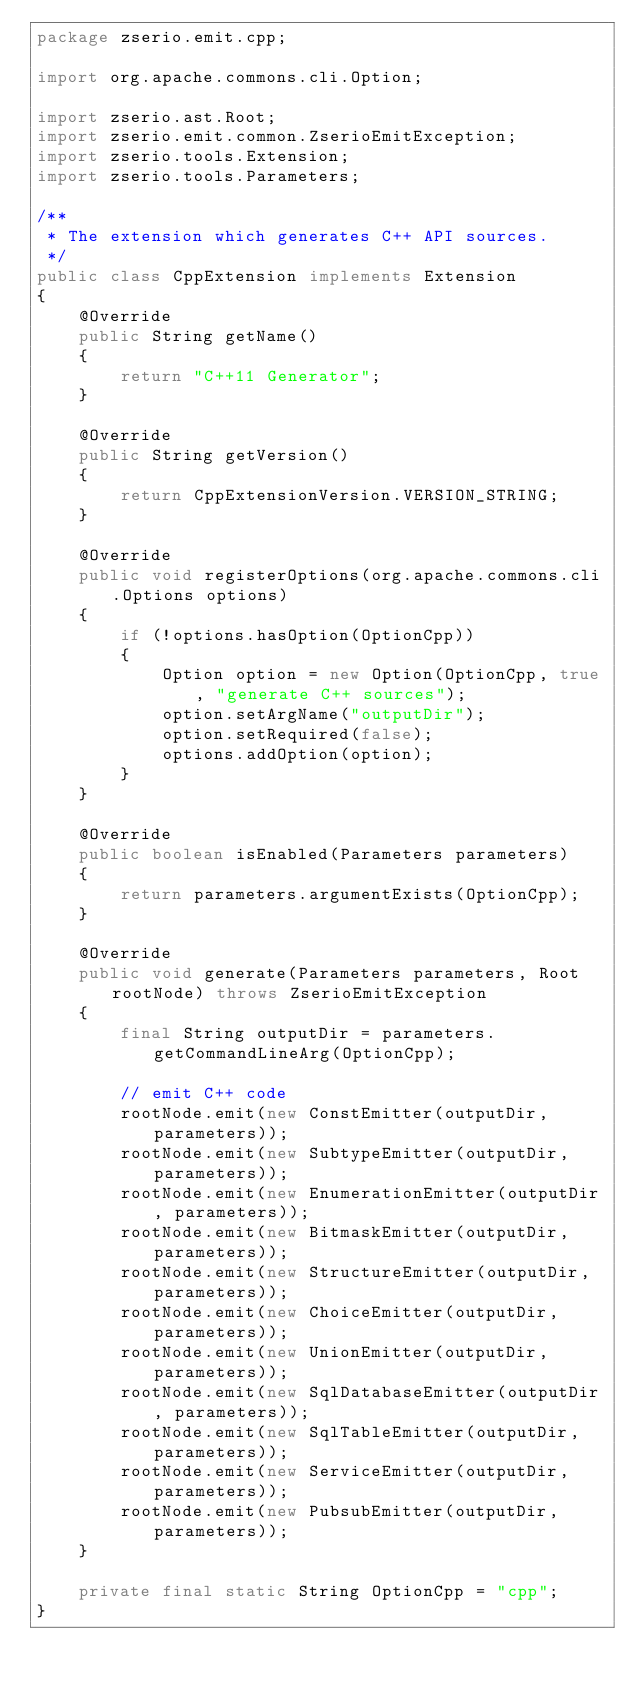Convert code to text. <code><loc_0><loc_0><loc_500><loc_500><_Java_>package zserio.emit.cpp;

import org.apache.commons.cli.Option;

import zserio.ast.Root;
import zserio.emit.common.ZserioEmitException;
import zserio.tools.Extension;
import zserio.tools.Parameters;

/**
 * The extension which generates C++ API sources.
 */
public class CppExtension implements Extension
{
    @Override
    public String getName()
    {
        return "C++11 Generator";
    }

    @Override
    public String getVersion()
    {
        return CppExtensionVersion.VERSION_STRING;
    }

    @Override
    public void registerOptions(org.apache.commons.cli.Options options)
    {
        if (!options.hasOption(OptionCpp))
        {
            Option option = new Option(OptionCpp, true, "generate C++ sources");
            option.setArgName("outputDir");
            option.setRequired(false);
            options.addOption(option);
        }
    }

    @Override
    public boolean isEnabled(Parameters parameters)
    {
        return parameters.argumentExists(OptionCpp);
    }

    @Override
    public void generate(Parameters parameters, Root rootNode) throws ZserioEmitException
    {
        final String outputDir = parameters.getCommandLineArg(OptionCpp);

        // emit C++ code
        rootNode.emit(new ConstEmitter(outputDir, parameters));
        rootNode.emit(new SubtypeEmitter(outputDir, parameters));
        rootNode.emit(new EnumerationEmitter(outputDir, parameters));
        rootNode.emit(new BitmaskEmitter(outputDir, parameters));
        rootNode.emit(new StructureEmitter(outputDir, parameters));
        rootNode.emit(new ChoiceEmitter(outputDir, parameters));
        rootNode.emit(new UnionEmitter(outputDir, parameters));
        rootNode.emit(new SqlDatabaseEmitter(outputDir, parameters));
        rootNode.emit(new SqlTableEmitter(outputDir, parameters));
        rootNode.emit(new ServiceEmitter(outputDir, parameters));
        rootNode.emit(new PubsubEmitter(outputDir, parameters));
    }

    private final static String OptionCpp = "cpp";
}
</code> 